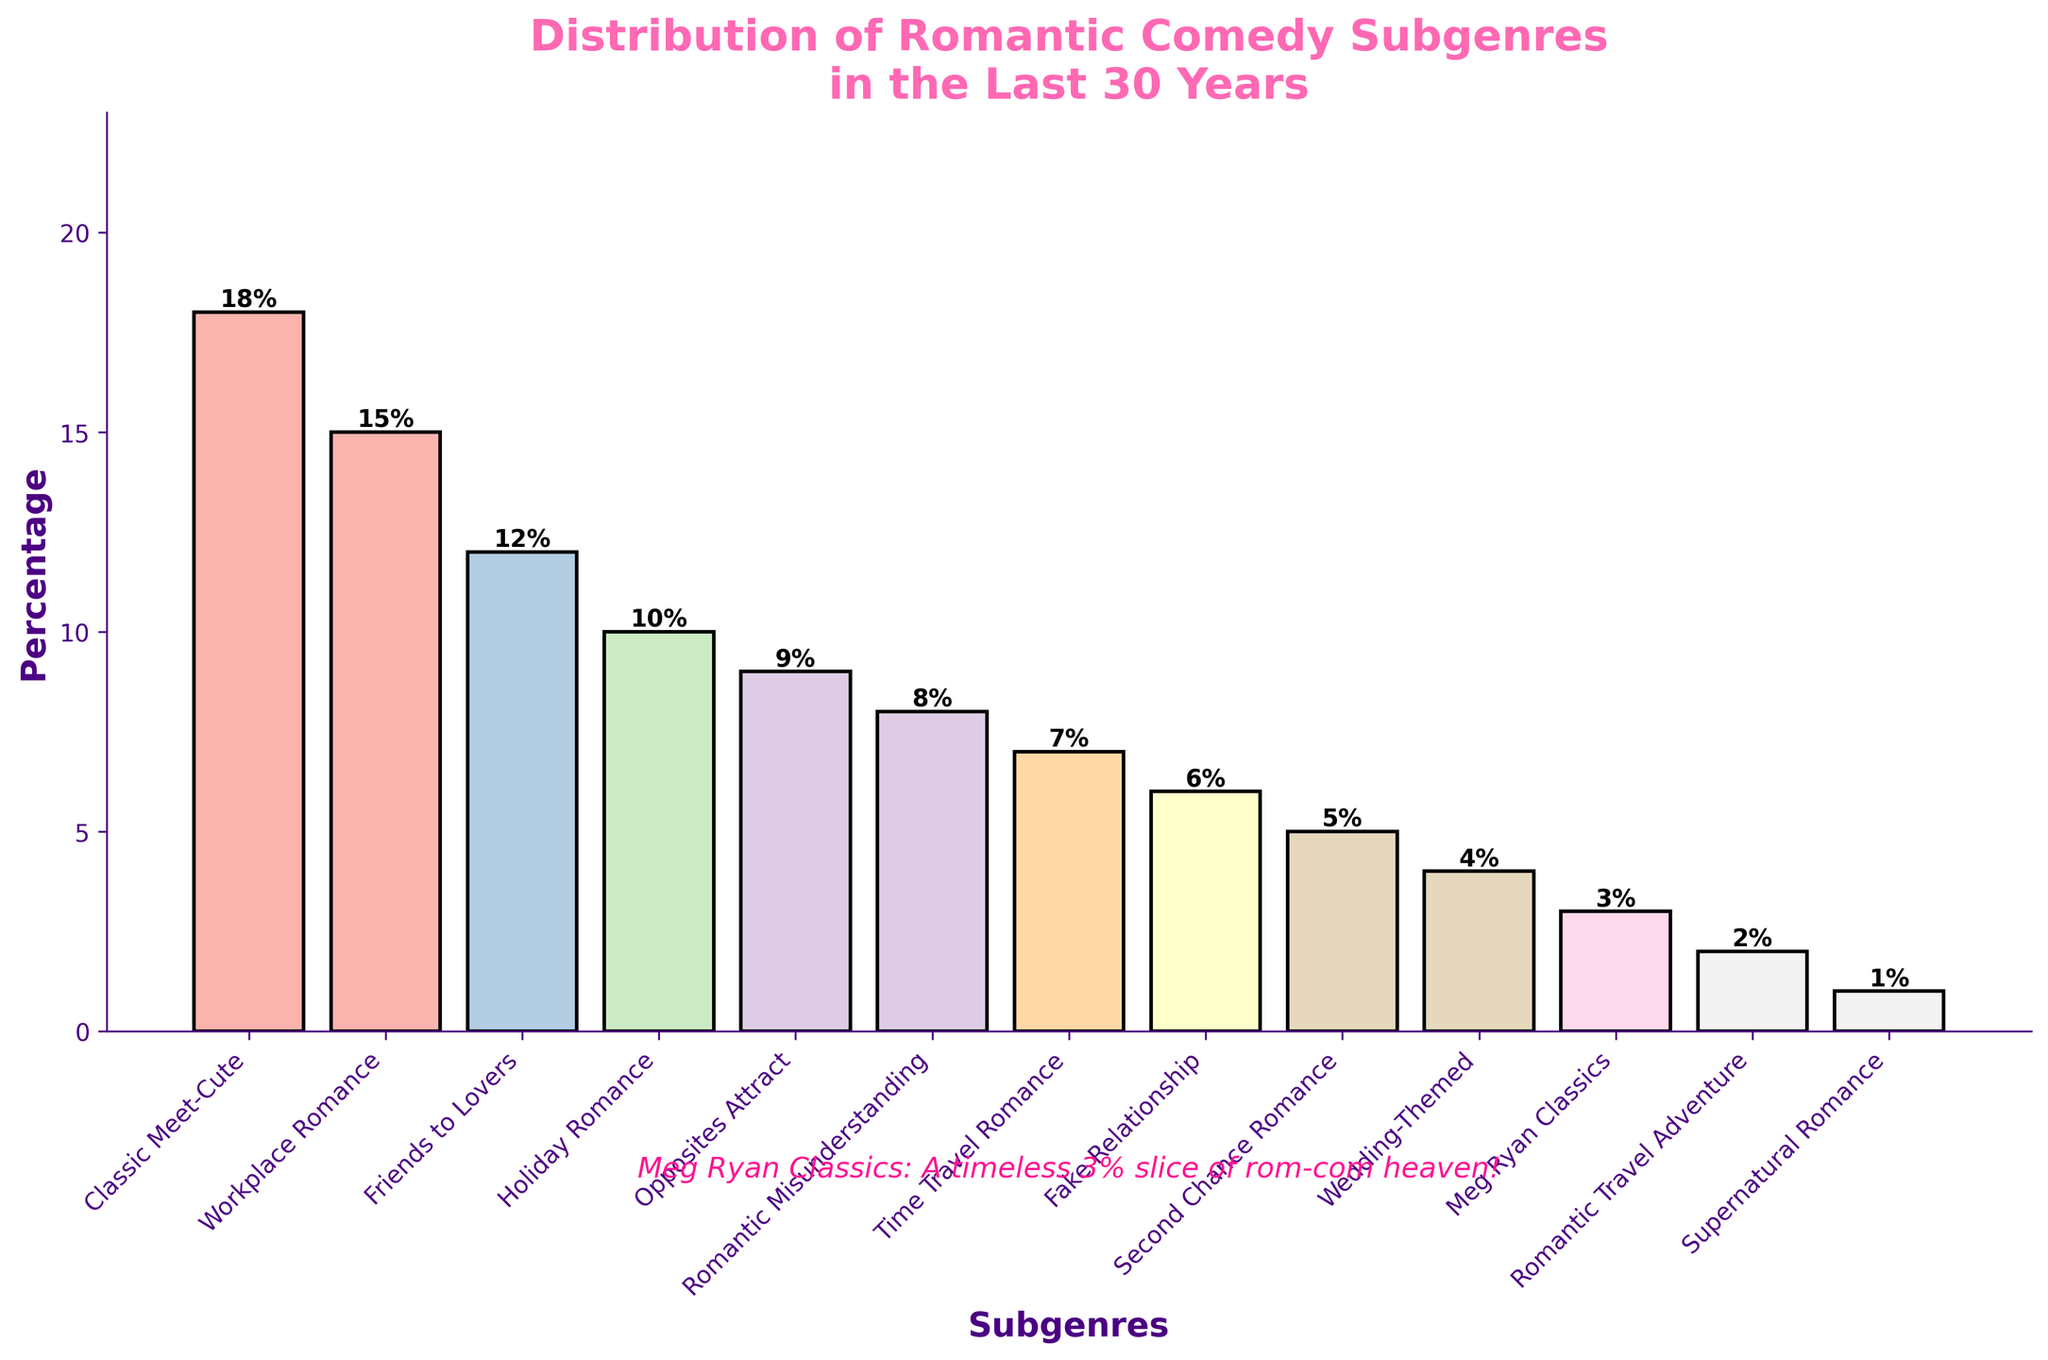What is the most common romantic comedy subgenre in the last 30 years? The bar chart shows the distribution of romantic comedy subgenres. The highest bar corresponds to "Classic Meet-Cute" at 18%.
Answer: Classic Meet-Cute Which subgenre has the lowest representation in the chart? The smallest bar corresponds to "Supernatural Romance" at 1%, indicating it has the lowest representation among the subgenres.
Answer: Supernatural Romance How does the percentage of "Workplace Romance" compare to "Holiday Romance"? The height of the "Workplace Romance" bar is 15% and the "Holiday Romance" bar is 10%. Comparatively, "Workplace Romance" is 5% higher than "Holiday Romance".
Answer: Workplace Romance is 5% higher than Holiday Romance What is the combined percentage of "Friends to Lovers" and "Opposites Attract"? "Friends to Lovers" is 12% and "Opposites Attract" is 9%. Summing these two percentages: 12% + 9% = 21%.
Answer: 21% What is the difference in the height of bars for "Romantic Misunderstanding" and "Fake Relationship"? The bar for "Romantic Misunderstanding" shows 8%, and the "Fake Relationship" shows 6%. The difference is 2%.
Answer: 2% Which subgenre appears to be nearly equal in representation to "Holiday Romance"? Both "Holiday Romance" (10%) and "Time Travel Romance" (7%) are close, but none are exactly equal. "Second Chance Romance" at 5% is the closest but not nearly equal.
Answer: None How many subgenres have a representation greater than or equal to 10%? By observing the chart, "*Classic Meet-Cute*" (18%), "Workplace Romance" (15%), "Friends to Lovers" (12%), and "Holiday Romance" (10%) all have percentages greater than or equal to 10%.
Answer: Four subgenres What is the range of percentages among all subgenres? The range is found by subtracting the smallest value (1% for "Supernatural Romance") from the highest value (18% for "Classic Meet-Cute"). The range is 18% - 1% = 17%.
Answer: 17% Is the percentage of "Meg Ryan Classics" more or less than "Wedding-Themed"? "Meg Ryan Classics" is at 3% and "Wedding-Themed" is at 4%. Therefore, "Meg Ryan Classics" is less than "Wedding-Themed" by 1%.
Answer: Less by 1% If you sum the percentages of "Romantic Travel Adventure" and "Second Chance Romance," how does it compare to "Opposites Attract"? "Romantic Travel Adventure" is 2% and "Second Chance Romance" is 5%. Their sum is 2% + 5% = 7%, which is less than "Opposites Attract" at 9%.
Answer: Less by 2% 